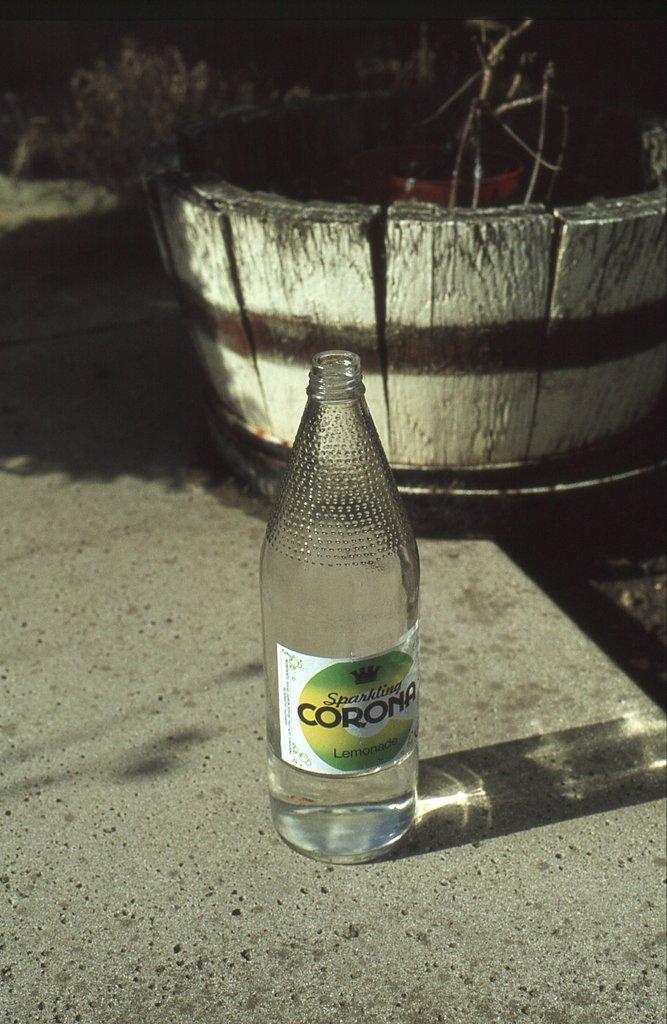What is the brand of the bottle?
Give a very brief answer. Corona. 